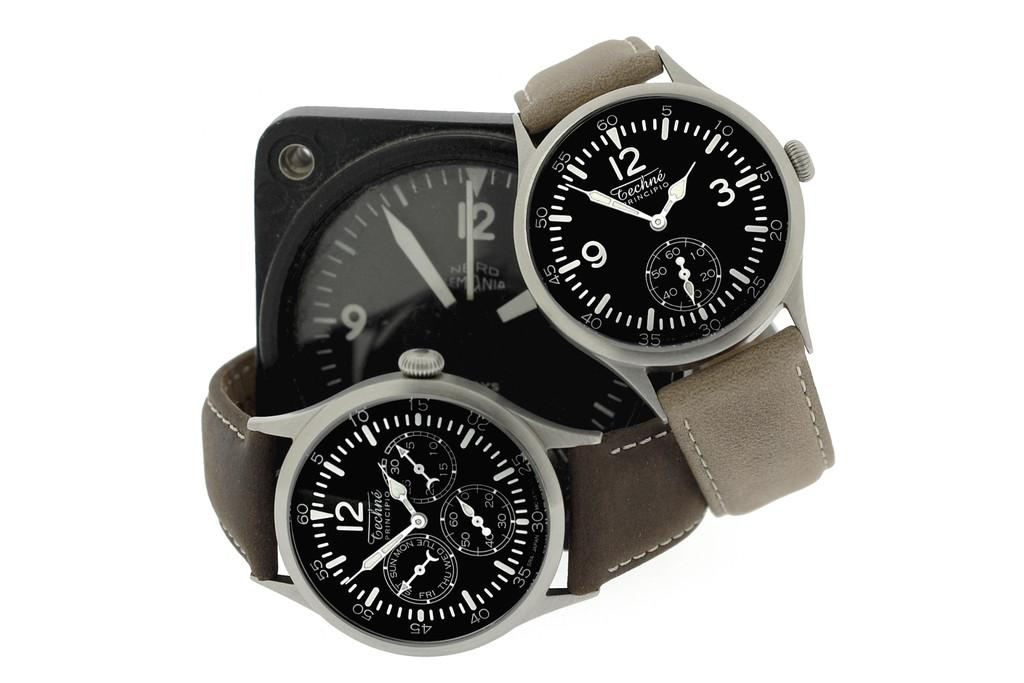<image>
Write a terse but informative summary of the picture. Several Techne brand watches and a clock are on display. 